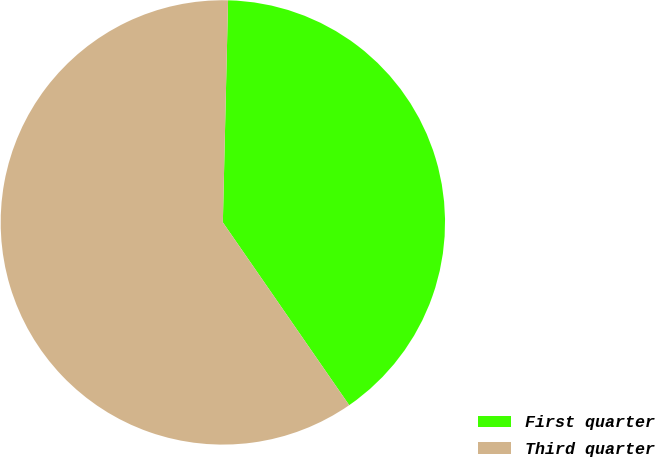Convert chart to OTSL. <chart><loc_0><loc_0><loc_500><loc_500><pie_chart><fcel>First quarter<fcel>Third quarter<nl><fcel>40.0%<fcel>60.0%<nl></chart> 